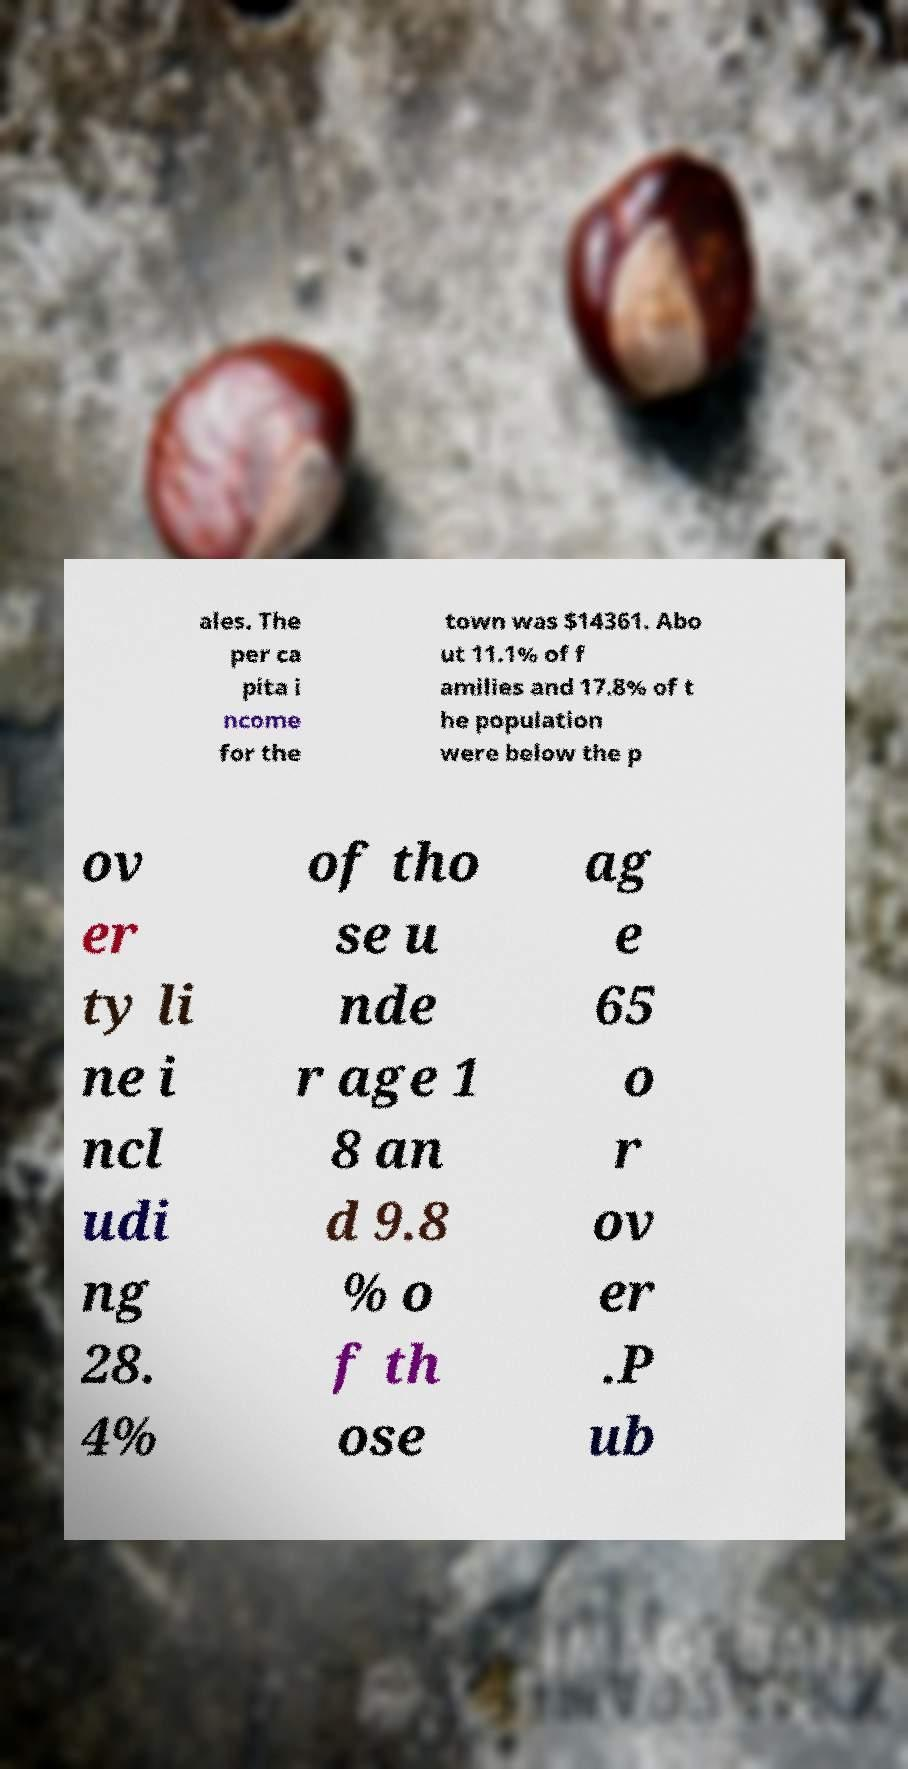What messages or text are displayed in this image? I need them in a readable, typed format. ales. The per ca pita i ncome for the town was $14361. Abo ut 11.1% of f amilies and 17.8% of t he population were below the p ov er ty li ne i ncl udi ng 28. 4% of tho se u nde r age 1 8 an d 9.8 % o f th ose ag e 65 o r ov er .P ub 